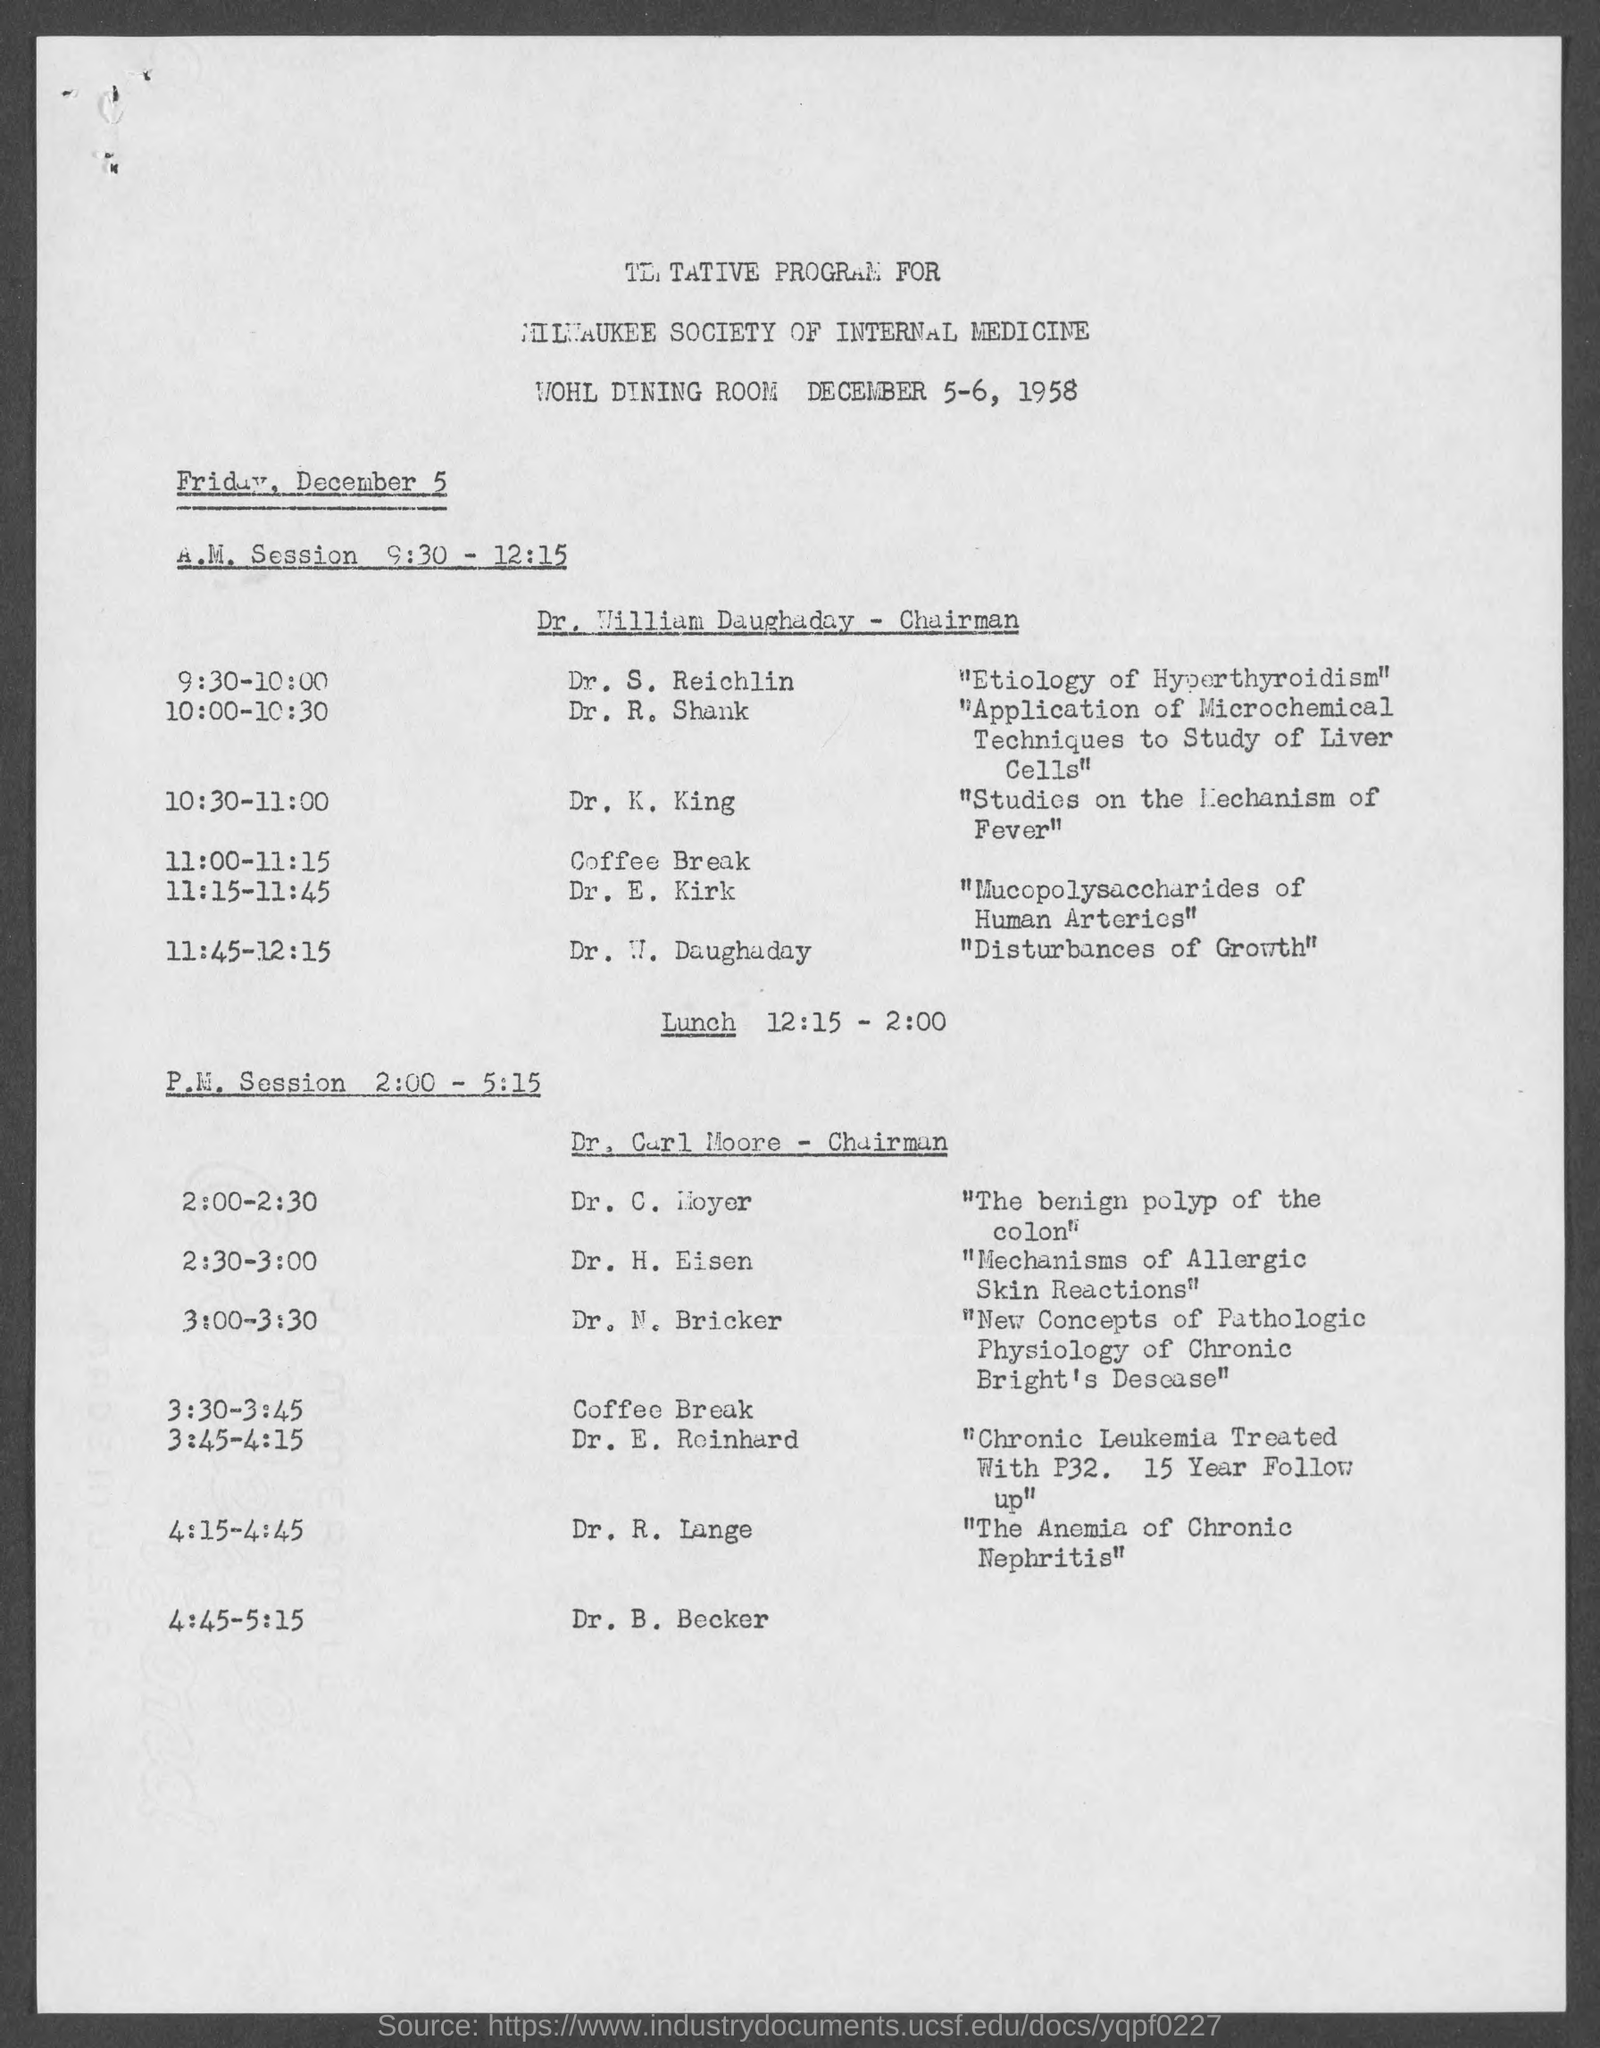Indicate a few pertinent items in this graphic. The program is scheduled to take place on December 5-6, 1958. On December 5, from 9:30 to 12:15, Dr. William Daughaday was the chairman for the A.M. session. On December 5, the P.M. Session is scheduled to take place from 2:00 PM to 5:15 PM. The speaker on the topic of "The Anemia of Chronic Nephritis" is identified as Dr. R. Lange. Dr. H. Eisen's topic is the mechanisms of allergic skin reactions. 